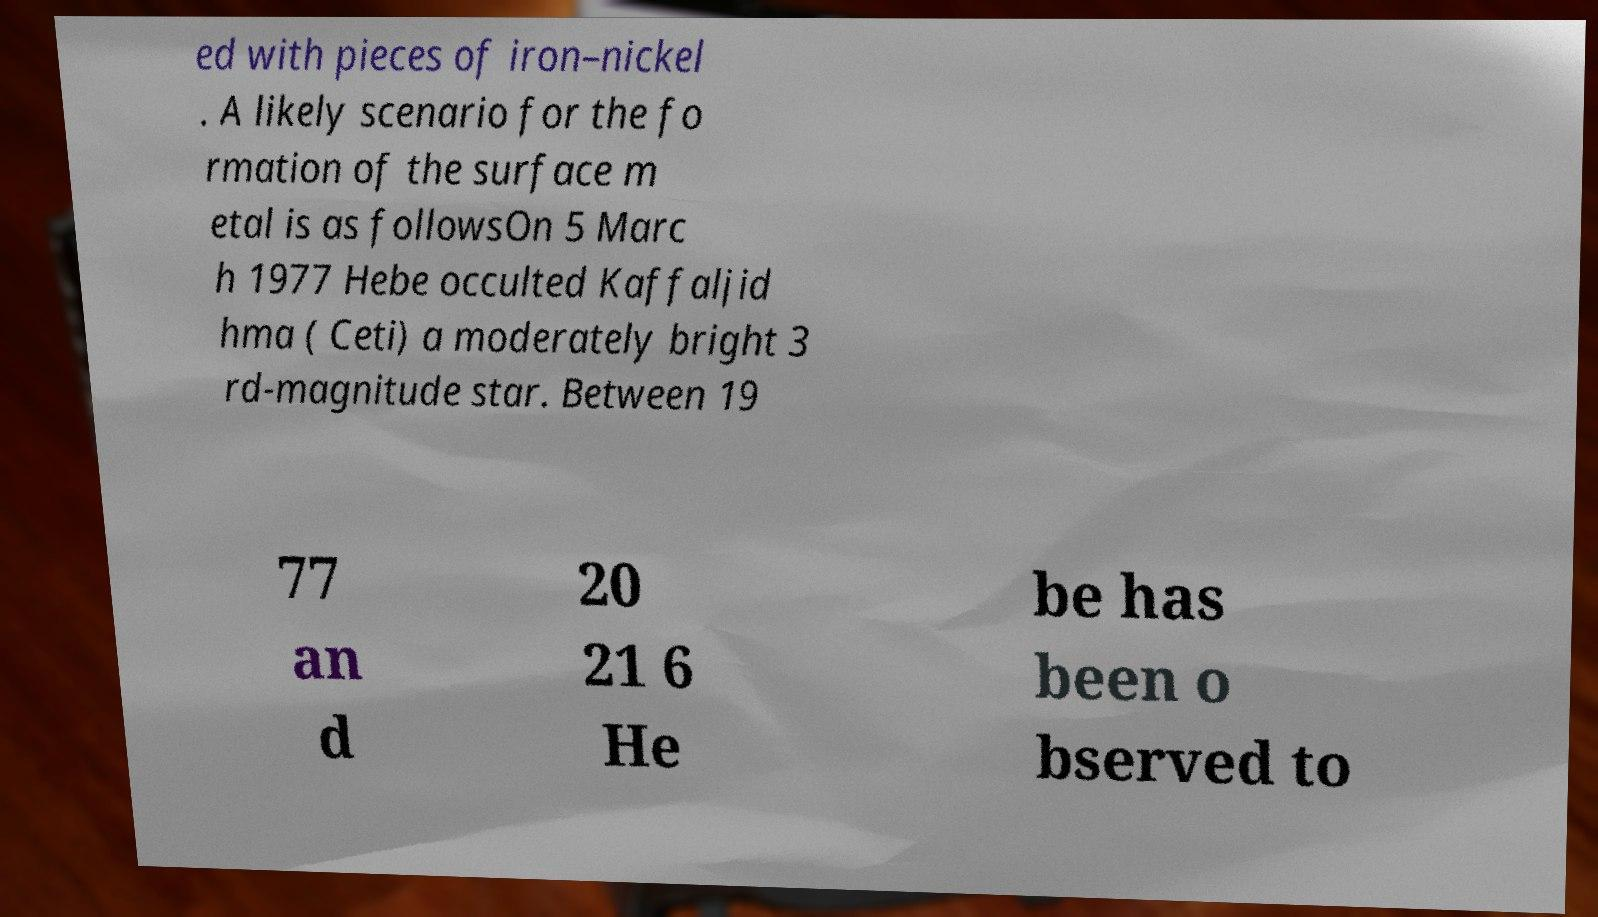Please read and relay the text visible in this image. What does it say? ed with pieces of iron–nickel . A likely scenario for the fo rmation of the surface m etal is as followsOn 5 Marc h 1977 Hebe occulted Kaffaljid hma ( Ceti) a moderately bright 3 rd-magnitude star. Between 19 77 an d 20 21 6 He be has been o bserved to 